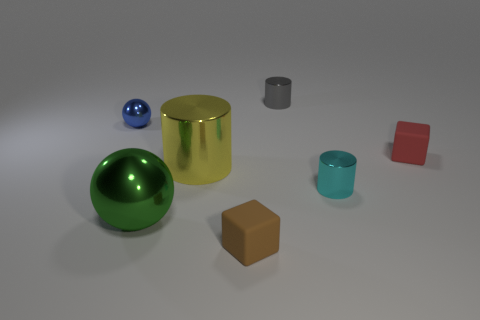What is the texture of the objects? Do they all appear smooth? The objects in the image generally appear to have a smooth surface, with reflections suggesting a shiny texture on the metallic ones, such as the cylinder and smaller balls. The non-metallic objects, while still smooth, lack the reflective quality of their metal counterparts. 